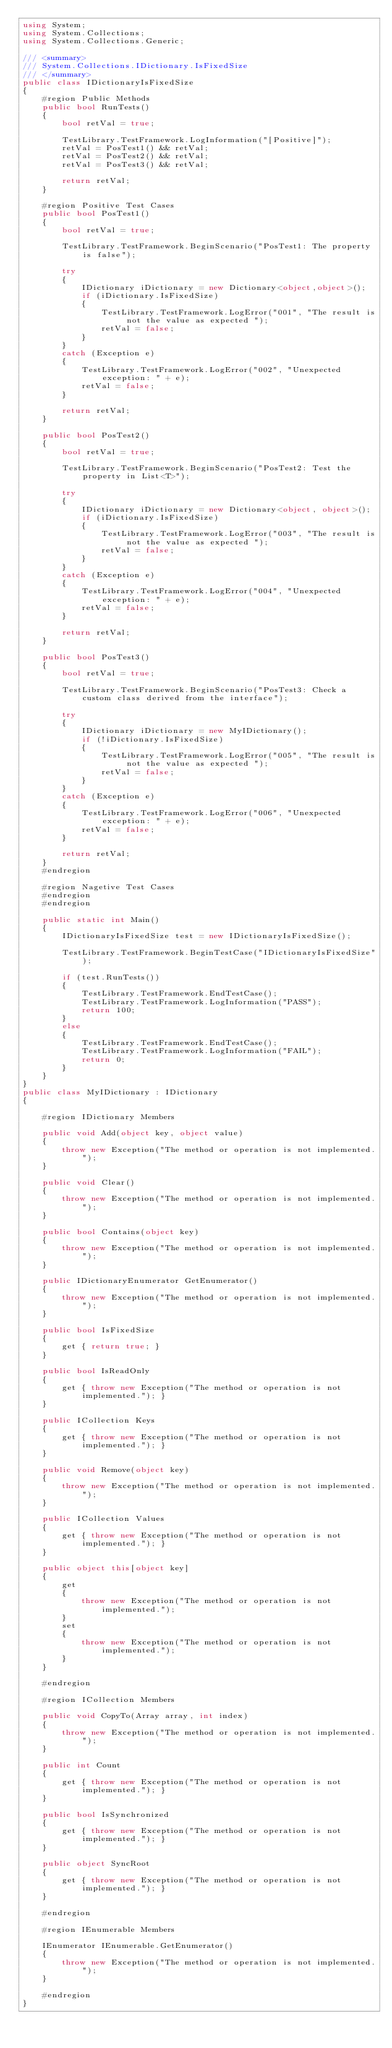Convert code to text. <code><loc_0><loc_0><loc_500><loc_500><_C#_>using System;
using System.Collections; 
using System.Collections.Generic;

/// <summary>
/// System.Collections.IDictionary.IsFixedSize
/// </summary>
public class IDictionaryIsFixedSize
{
    #region Public Methods
    public bool RunTests()
    {
        bool retVal = true;

        TestLibrary.TestFramework.LogInformation("[Positive]");
        retVal = PosTest1() && retVal;
        retVal = PosTest2() && retVal;
        retVal = PosTest3() && retVal;

        return retVal;
    }

    #region Positive Test Cases
    public bool PosTest1()
    {
        bool retVal = true;

        TestLibrary.TestFramework.BeginScenario("PosTest1: The property is false");

        try
        {
            IDictionary iDictionary = new Dictionary<object,object>();
            if (iDictionary.IsFixedSize)
            {
                TestLibrary.TestFramework.LogError("001", "The result is not the value as expected ");
                retVal = false;
            }
        }
        catch (Exception e)
        {
            TestLibrary.TestFramework.LogError("002", "Unexpected exception: " + e);
            retVal = false;
        }

        return retVal;
    }

    public bool PosTest2()
    {
        bool retVal = true;

        TestLibrary.TestFramework.BeginScenario("PosTest2: Test the property in List<T>");

        try
        {
            IDictionary iDictionary = new Dictionary<object, object>();
            if (iDictionary.IsFixedSize)
            {
                TestLibrary.TestFramework.LogError("003", "The result is not the value as expected ");
                retVal = false;
            }
        }
        catch (Exception e)
        {
            TestLibrary.TestFramework.LogError("004", "Unexpected exception: " + e);
            retVal = false;
        }

        return retVal;
    }

    public bool PosTest3()
    {
        bool retVal = true;

        TestLibrary.TestFramework.BeginScenario("PosTest3: Check a custom class derived from the interface");

        try
        {
            IDictionary iDictionary = new MyIDictionary();
            if (!iDictionary.IsFixedSize)
            {
                TestLibrary.TestFramework.LogError("005", "The result is not the value as expected ");
                retVal = false;
            }
        }
        catch (Exception e)
        {
            TestLibrary.TestFramework.LogError("006", "Unexpected exception: " + e);
            retVal = false;
        }

        return retVal;
    }
    #endregion

    #region Nagetive Test Cases
    #endregion
    #endregion

    public static int Main()
    {
        IDictionaryIsFixedSize test = new IDictionaryIsFixedSize();

        TestLibrary.TestFramework.BeginTestCase("IDictionaryIsFixedSize");

        if (test.RunTests())
        {
            TestLibrary.TestFramework.EndTestCase();
            TestLibrary.TestFramework.LogInformation("PASS");
            return 100;
        }
        else
        {
            TestLibrary.TestFramework.EndTestCase();
            TestLibrary.TestFramework.LogInformation("FAIL");
            return 0;
        }
    }
}
public class MyIDictionary : IDictionary
{

    #region IDictionary Members

    public void Add(object key, object value)
    {
        throw new Exception("The method or operation is not implemented.");
    }

    public void Clear()
    {
        throw new Exception("The method or operation is not implemented.");
    }

    public bool Contains(object key)
    {
        throw new Exception("The method or operation is not implemented.");
    }

    public IDictionaryEnumerator GetEnumerator()
    {
        throw new Exception("The method or operation is not implemented.");
    }

    public bool IsFixedSize
    {
        get { return true; }
    }

    public bool IsReadOnly
    {
        get { throw new Exception("The method or operation is not implemented."); }
    }

    public ICollection Keys
    {
        get { throw new Exception("The method or operation is not implemented."); }
    }

    public void Remove(object key)
    {
        throw new Exception("The method or operation is not implemented.");
    }

    public ICollection Values
    {
        get { throw new Exception("The method or operation is not implemented."); }
    }

    public object this[object key]
    {
        get
        {
            throw new Exception("The method or operation is not implemented.");
        }
        set
        {
            throw new Exception("The method or operation is not implemented.");
        }
    }

    #endregion

    #region ICollection Members

    public void CopyTo(Array array, int index)
    {
        throw new Exception("The method or operation is not implemented.");
    }

    public int Count
    {
        get { throw new Exception("The method or operation is not implemented."); }
    }

    public bool IsSynchronized
    {
        get { throw new Exception("The method or operation is not implemented."); }
    }

    public object SyncRoot
    {
        get { throw new Exception("The method or operation is not implemented."); }
    }

    #endregion

    #region IEnumerable Members

    IEnumerator IEnumerable.GetEnumerator()
    {
        throw new Exception("The method or operation is not implemented.");
    }

    #endregion
}</code> 